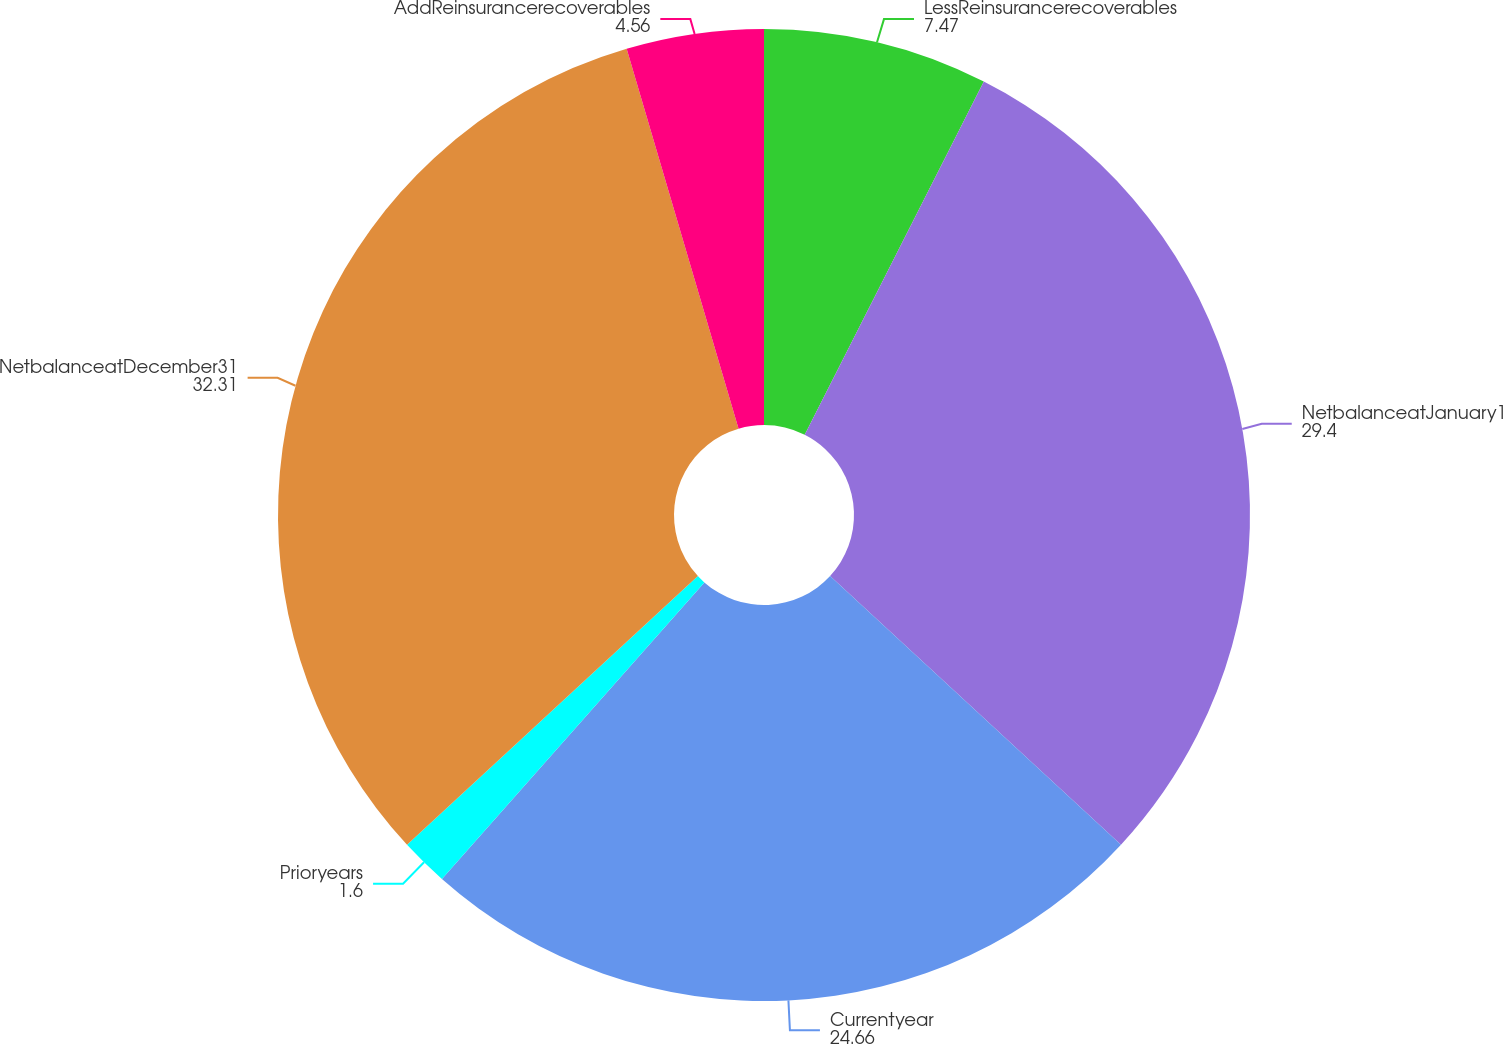Convert chart. <chart><loc_0><loc_0><loc_500><loc_500><pie_chart><fcel>LessReinsurancerecoverables<fcel>NetbalanceatJanuary1<fcel>Currentyear<fcel>Prioryears<fcel>NetbalanceatDecember31<fcel>AddReinsurancerecoverables<nl><fcel>7.47%<fcel>29.4%<fcel>24.66%<fcel>1.6%<fcel>32.31%<fcel>4.56%<nl></chart> 